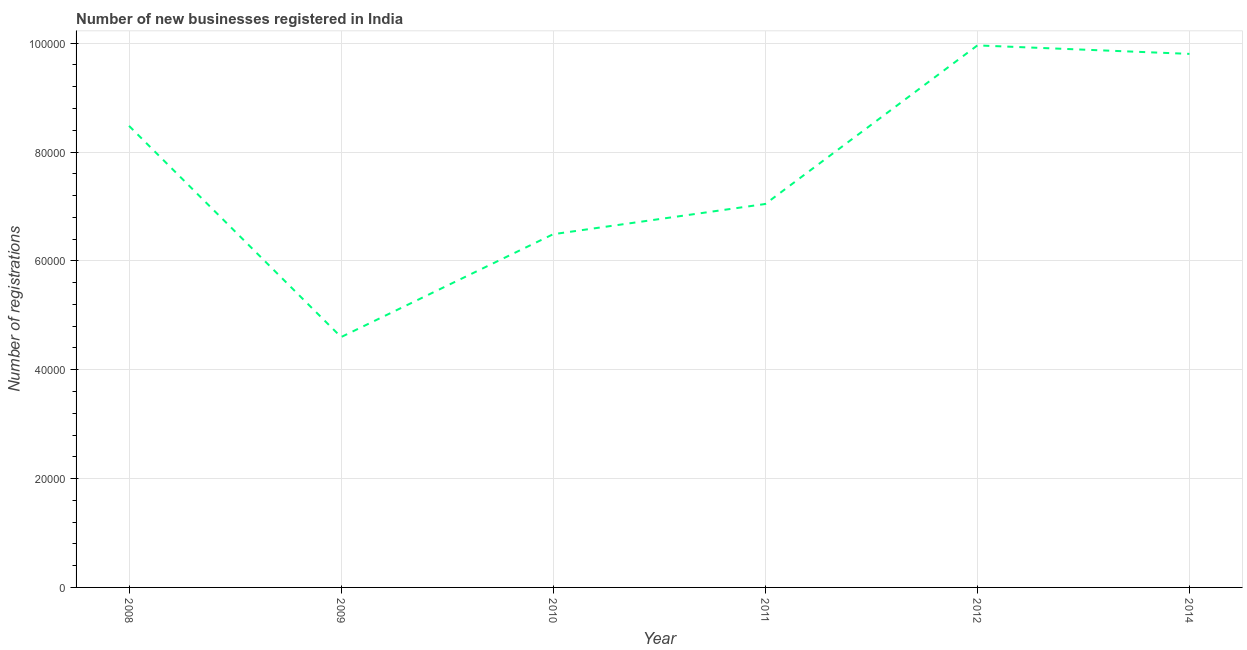What is the number of new business registrations in 2012?
Your answer should be very brief. 9.96e+04. Across all years, what is the maximum number of new business registrations?
Keep it short and to the point. 9.96e+04. Across all years, what is the minimum number of new business registrations?
Ensure brevity in your answer.  4.60e+04. In which year was the number of new business registrations minimum?
Your answer should be very brief. 2009. What is the sum of the number of new business registrations?
Your answer should be very brief. 4.64e+05. What is the difference between the number of new business registrations in 2011 and 2014?
Keep it short and to the point. -2.76e+04. What is the average number of new business registrations per year?
Your answer should be very brief. 7.73e+04. What is the median number of new business registrations?
Provide a short and direct response. 7.76e+04. What is the ratio of the number of new business registrations in 2011 to that in 2014?
Offer a very short reply. 0.72. What is the difference between the highest and the second highest number of new business registrations?
Your response must be concise. 1558. Is the sum of the number of new business registrations in 2009 and 2012 greater than the maximum number of new business registrations across all years?
Your answer should be very brief. Yes. What is the difference between the highest and the lowest number of new business registrations?
Your response must be concise. 5.36e+04. Does the number of new business registrations monotonically increase over the years?
Your answer should be very brief. No. How many years are there in the graph?
Ensure brevity in your answer.  6. What is the difference between two consecutive major ticks on the Y-axis?
Your answer should be compact. 2.00e+04. Are the values on the major ticks of Y-axis written in scientific E-notation?
Your answer should be compact. No. Does the graph contain grids?
Your answer should be compact. Yes. What is the title of the graph?
Your answer should be very brief. Number of new businesses registered in India. What is the label or title of the Y-axis?
Make the answer very short. Number of registrations. What is the Number of registrations of 2008?
Give a very brief answer. 8.48e+04. What is the Number of registrations of 2009?
Your answer should be very brief. 4.60e+04. What is the Number of registrations in 2010?
Offer a very short reply. 6.49e+04. What is the Number of registrations in 2011?
Your answer should be compact. 7.04e+04. What is the Number of registrations of 2012?
Make the answer very short. 9.96e+04. What is the Number of registrations of 2014?
Keep it short and to the point. 9.80e+04. What is the difference between the Number of registrations in 2008 and 2009?
Provide a short and direct response. 3.88e+04. What is the difference between the Number of registrations in 2008 and 2010?
Provide a succinct answer. 1.99e+04. What is the difference between the Number of registrations in 2008 and 2011?
Offer a terse response. 1.44e+04. What is the difference between the Number of registrations in 2008 and 2012?
Give a very brief answer. -1.48e+04. What is the difference between the Number of registrations in 2008 and 2014?
Provide a succinct answer. -1.32e+04. What is the difference between the Number of registrations in 2009 and 2010?
Keep it short and to the point. -1.89e+04. What is the difference between the Number of registrations in 2009 and 2011?
Your answer should be very brief. -2.44e+04. What is the difference between the Number of registrations in 2009 and 2012?
Keep it short and to the point. -5.36e+04. What is the difference between the Number of registrations in 2009 and 2014?
Offer a terse response. -5.20e+04. What is the difference between the Number of registrations in 2010 and 2011?
Your response must be concise. -5550. What is the difference between the Number of registrations in 2010 and 2012?
Give a very brief answer. -3.47e+04. What is the difference between the Number of registrations in 2010 and 2014?
Your answer should be very brief. -3.31e+04. What is the difference between the Number of registrations in 2011 and 2012?
Offer a very short reply. -2.91e+04. What is the difference between the Number of registrations in 2011 and 2014?
Your answer should be very brief. -2.76e+04. What is the difference between the Number of registrations in 2012 and 2014?
Provide a short and direct response. 1558. What is the ratio of the Number of registrations in 2008 to that in 2009?
Ensure brevity in your answer.  1.84. What is the ratio of the Number of registrations in 2008 to that in 2010?
Provide a short and direct response. 1.31. What is the ratio of the Number of registrations in 2008 to that in 2011?
Make the answer very short. 1.2. What is the ratio of the Number of registrations in 2008 to that in 2012?
Your answer should be compact. 0.85. What is the ratio of the Number of registrations in 2008 to that in 2014?
Offer a terse response. 0.86. What is the ratio of the Number of registrations in 2009 to that in 2010?
Provide a short and direct response. 0.71. What is the ratio of the Number of registrations in 2009 to that in 2011?
Offer a very short reply. 0.65. What is the ratio of the Number of registrations in 2009 to that in 2012?
Provide a succinct answer. 0.46. What is the ratio of the Number of registrations in 2009 to that in 2014?
Your response must be concise. 0.47. What is the ratio of the Number of registrations in 2010 to that in 2011?
Ensure brevity in your answer.  0.92. What is the ratio of the Number of registrations in 2010 to that in 2012?
Provide a short and direct response. 0.65. What is the ratio of the Number of registrations in 2010 to that in 2014?
Keep it short and to the point. 0.66. What is the ratio of the Number of registrations in 2011 to that in 2012?
Provide a succinct answer. 0.71. What is the ratio of the Number of registrations in 2011 to that in 2014?
Your response must be concise. 0.72. What is the ratio of the Number of registrations in 2012 to that in 2014?
Your answer should be compact. 1.02. 